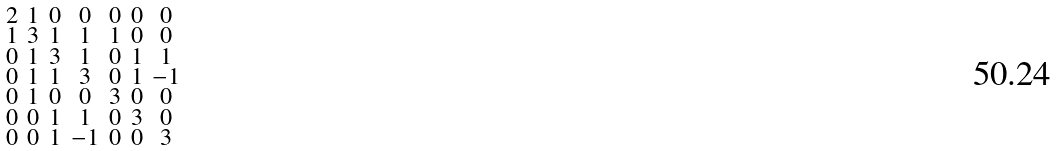<formula> <loc_0><loc_0><loc_500><loc_500>\begin{smallmatrix} 2 & 1 & 0 & 0 & 0 & 0 & 0 \\ 1 & 3 & 1 & 1 & 1 & 0 & 0 \\ 0 & 1 & 3 & 1 & 0 & 1 & 1 \\ 0 & 1 & 1 & 3 & 0 & 1 & - 1 \\ 0 & 1 & 0 & 0 & 3 & 0 & 0 \\ 0 & 0 & 1 & 1 & 0 & 3 & 0 \\ 0 & 0 & 1 & - 1 & 0 & 0 & 3 \end{smallmatrix}</formula> 